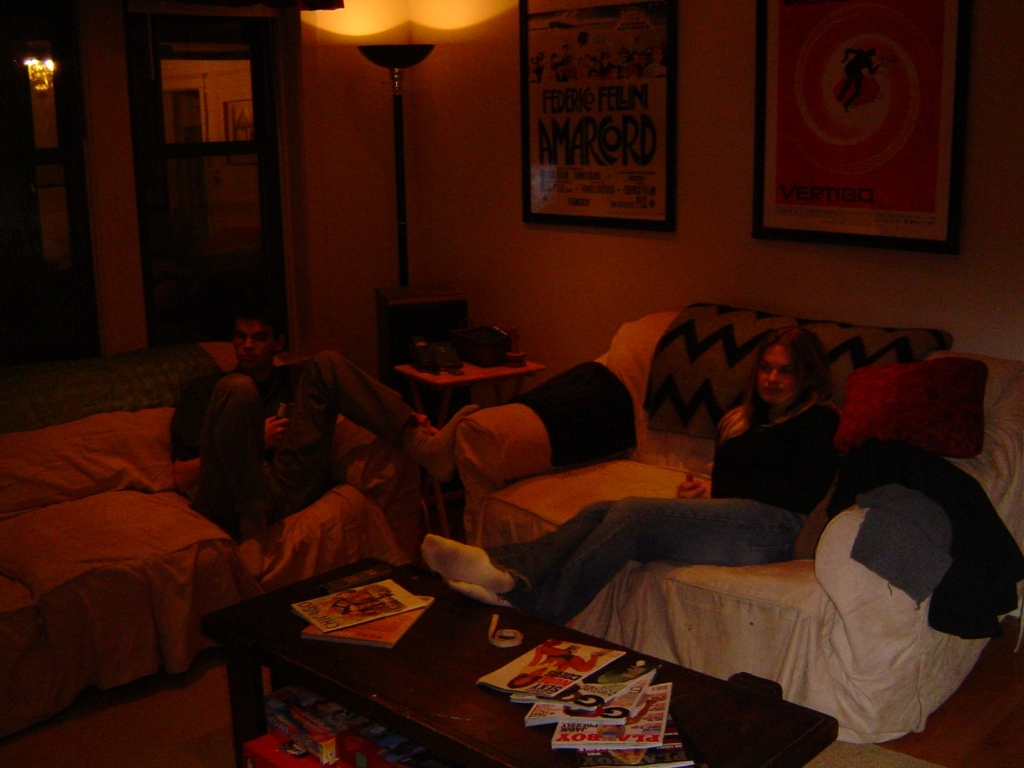Can you describe the room and the atmosphere? The room has a cozy and informal atmosphere, conveyed by the soft lighting and relaxed postures of the individuals on the couch. There are personal touches such as movie posters on the wall, hinting at an interest in cinema. The room appears lived-in, with magazines and various items casually placed on the coffee table, suggesting a laid-back, comfortable setting. What time of day does it seem to be? Given the visible darkness outside the window and the overall dim lighting of the room, it appears to be evening or night. The indoor lights add a warm ambience, which typically suggests it's a time for relaxation or winding down after the day. 